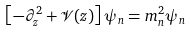Convert formula to latex. <formula><loc_0><loc_0><loc_500><loc_500>\left [ - \partial _ { z } ^ { 2 } + \mathcal { V } ( z ) \right ] \psi _ { n } = m _ { n } ^ { 2 } \psi _ { n }</formula> 